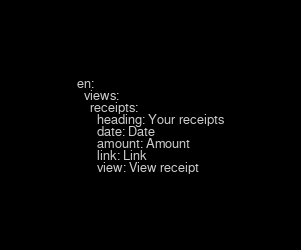<code> <loc_0><loc_0><loc_500><loc_500><_YAML_>en:
  views:
    receipts:
      heading: Your receipts
      date: Date
      amount: Amount
      link: Link
      view: View receipt
</code> 